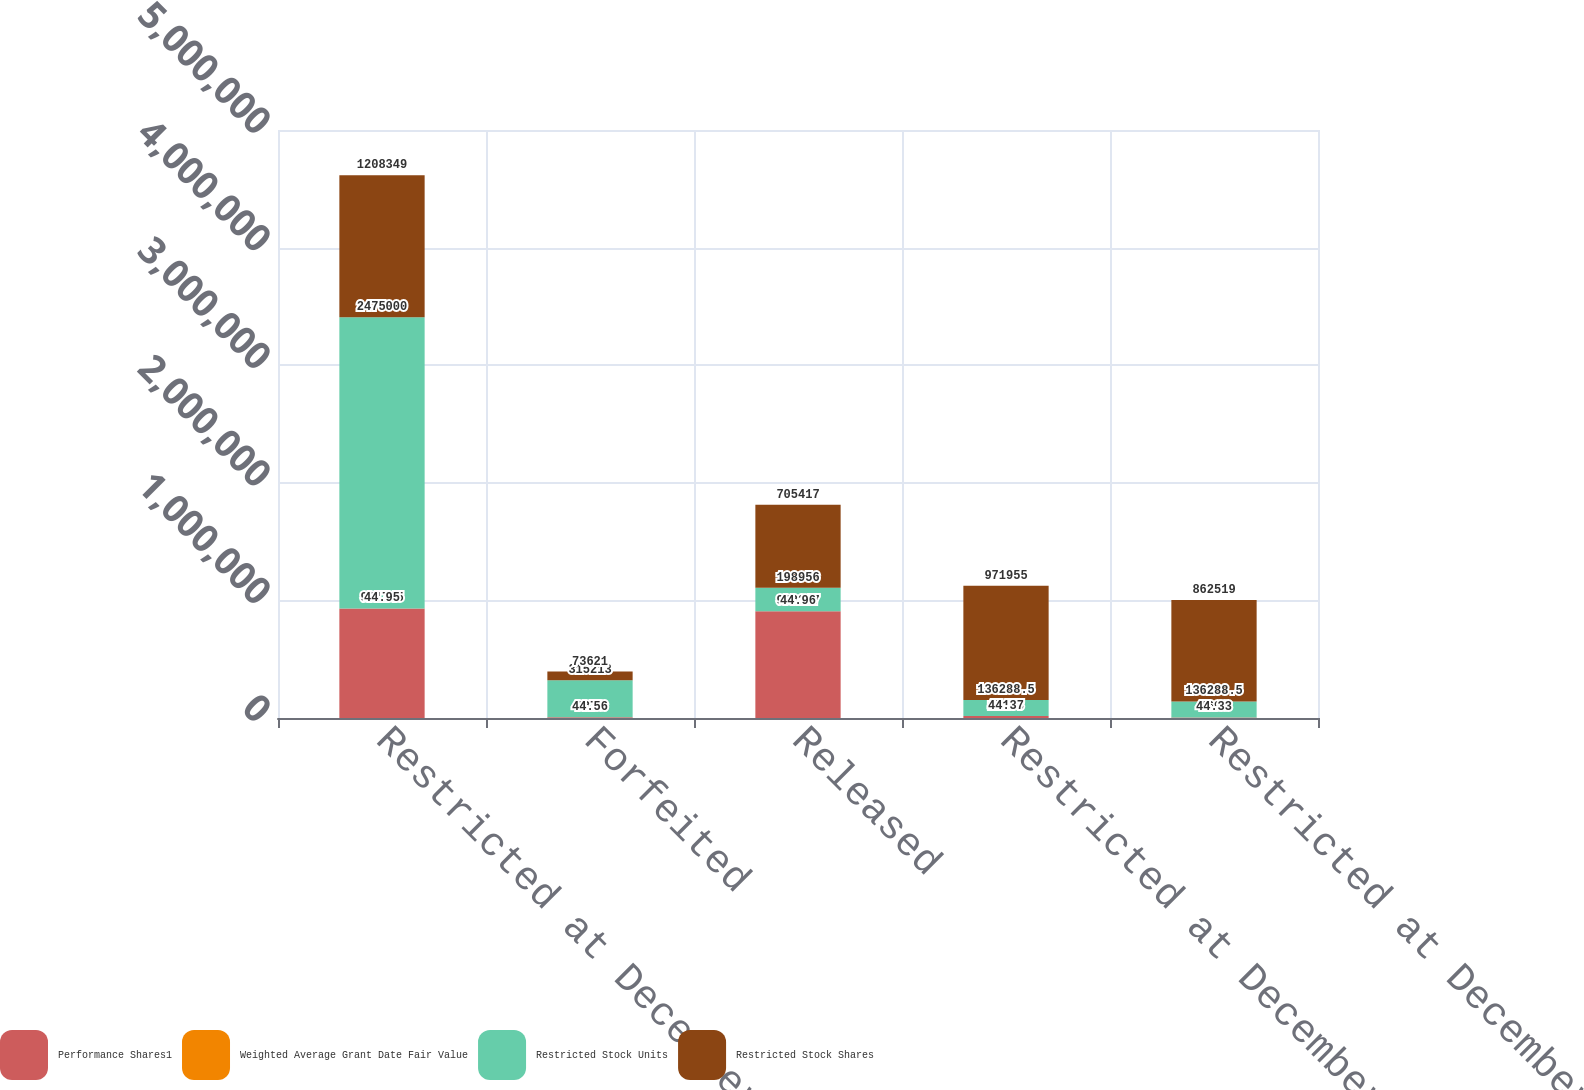Convert chart. <chart><loc_0><loc_0><loc_500><loc_500><stacked_bar_chart><ecel><fcel>Restricted at December 31 2006<fcel>Forfeited<fcel>Released<fcel>Restricted at December 31 2007<fcel>Restricted at December 31 2008<nl><fcel>Performance Shares1<fcel>931745<fcel>6370<fcel>908217<fcel>17158<fcel>4690<nl><fcel>Weighted Average Grant Date Fair Value<fcel>44.95<fcel>44.56<fcel>44.96<fcel>44.37<fcel>44.33<nl><fcel>Restricted Stock Units<fcel>2.475e+06<fcel>315213<fcel>198956<fcel>136288<fcel>136288<nl><fcel>Restricted Stock Shares<fcel>1.20835e+06<fcel>73621<fcel>705417<fcel>971955<fcel>862519<nl></chart> 